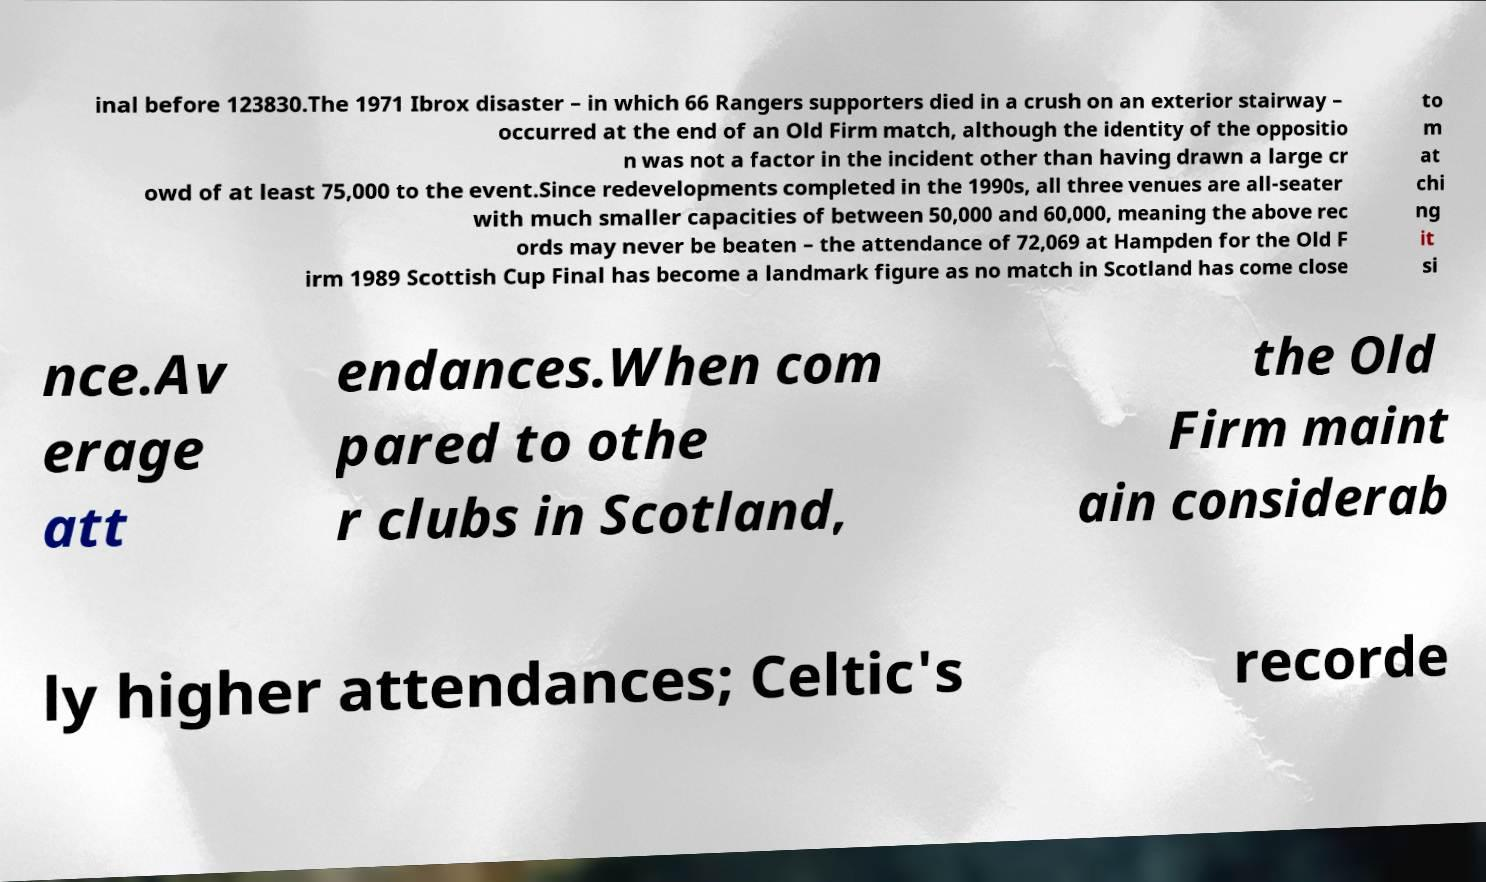What messages or text are displayed in this image? I need them in a readable, typed format. inal before 123830.The 1971 Ibrox disaster – in which 66 Rangers supporters died in a crush on an exterior stairway – occurred at the end of an Old Firm match, although the identity of the oppositio n was not a factor in the incident other than having drawn a large cr owd of at least 75,000 to the event.Since redevelopments completed in the 1990s, all three venues are all-seater with much smaller capacities of between 50,000 and 60,000, meaning the above rec ords may never be beaten – the attendance of 72,069 at Hampden for the Old F irm 1989 Scottish Cup Final has become a landmark figure as no match in Scotland has come close to m at chi ng it si nce.Av erage att endances.When com pared to othe r clubs in Scotland, the Old Firm maint ain considerab ly higher attendances; Celtic's recorde 